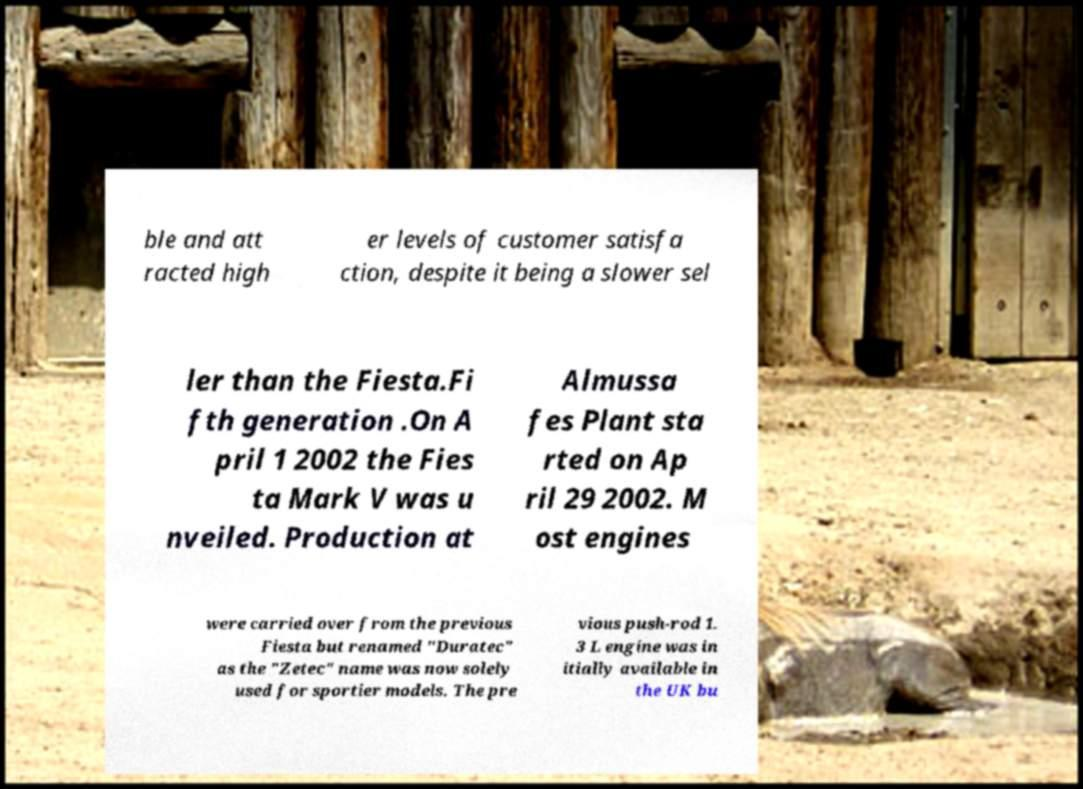Can you accurately transcribe the text from the provided image for me? ble and att racted high er levels of customer satisfa ction, despite it being a slower sel ler than the Fiesta.Fi fth generation .On A pril 1 2002 the Fies ta Mark V was u nveiled. Production at Almussa fes Plant sta rted on Ap ril 29 2002. M ost engines were carried over from the previous Fiesta but renamed "Duratec" as the "Zetec" name was now solely used for sportier models. The pre vious push-rod 1. 3 L engine was in itially available in the UK bu 